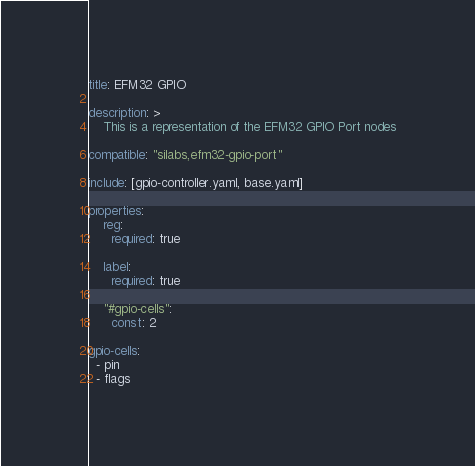<code> <loc_0><loc_0><loc_500><loc_500><_YAML_>title: EFM32 GPIO

description: >
    This is a representation of the EFM32 GPIO Port nodes

compatible: "silabs,efm32-gpio-port"

include: [gpio-controller.yaml, base.yaml]

properties:
    reg:
      required: true

    label:
      required: true

    "#gpio-cells":
      const: 2

gpio-cells:
  - pin
  - flags
</code> 